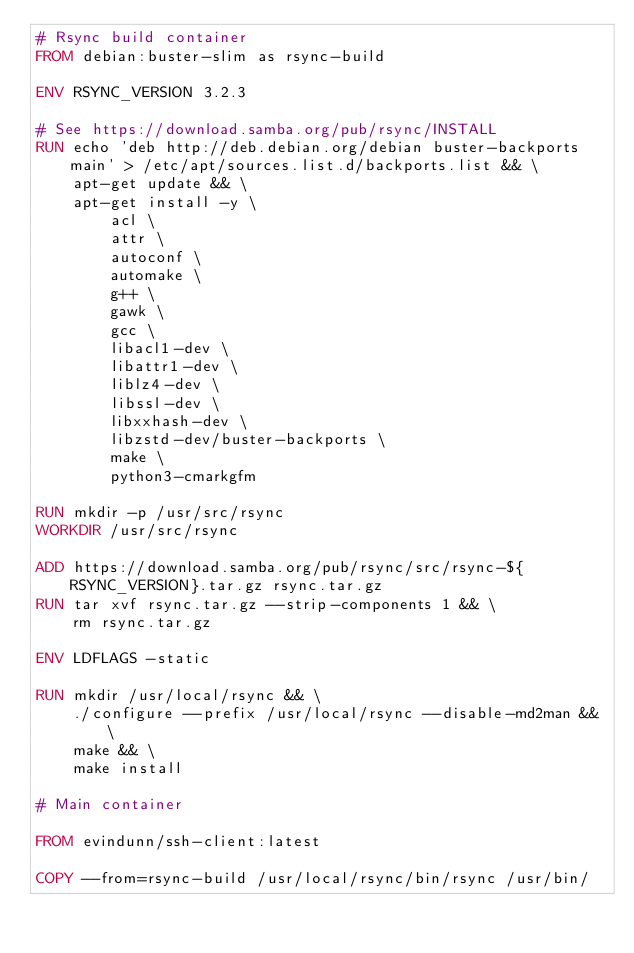<code> <loc_0><loc_0><loc_500><loc_500><_Dockerfile_># Rsync build container
FROM debian:buster-slim as rsync-build

ENV RSYNC_VERSION 3.2.3

# See https://download.samba.org/pub/rsync/INSTALL
RUN echo 'deb http://deb.debian.org/debian buster-backports main' > /etc/apt/sources.list.d/backports.list && \
    apt-get update && \
    apt-get install -y \
        acl \
        attr \
        autoconf \
        automake \
        g++ \
        gawk \
        gcc \
        libacl1-dev \
        libattr1-dev \
        liblz4-dev \
        libssl-dev \
        libxxhash-dev \
        libzstd-dev/buster-backports \
        make \
        python3-cmarkgfm

RUN mkdir -p /usr/src/rsync
WORKDIR /usr/src/rsync

ADD https://download.samba.org/pub/rsync/src/rsync-${RSYNC_VERSION}.tar.gz rsync.tar.gz
RUN tar xvf rsync.tar.gz --strip-components 1 && \
    rm rsync.tar.gz

ENV LDFLAGS -static

RUN mkdir /usr/local/rsync && \
    ./configure --prefix /usr/local/rsync --disable-md2man && \
    make && \
    make install

# Main container

FROM evindunn/ssh-client:latest

COPY --from=rsync-build /usr/local/rsync/bin/rsync /usr/bin/
</code> 